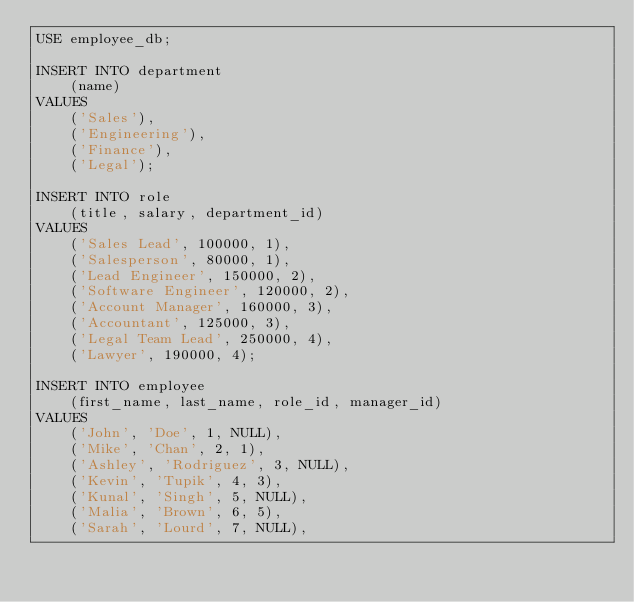Convert code to text. <code><loc_0><loc_0><loc_500><loc_500><_SQL_>USE employee_db;

INSERT INTO department
    (name)
VALUES
    ('Sales'),
    ('Engineering'),
    ('Finance'),
    ('Legal');

INSERT INTO role
    (title, salary, department_id)
VALUES
    ('Sales Lead', 100000, 1),
    ('Salesperson', 80000, 1),
    ('Lead Engineer', 150000, 2),
    ('Software Engineer', 120000, 2),
    ('Account Manager', 160000, 3),
    ('Accountant', 125000, 3),
    ('Legal Team Lead', 250000, 4),
    ('Lawyer', 190000, 4);

INSERT INTO employee
    (first_name, last_name, role_id, manager_id)
VALUES
    ('John', 'Doe', 1, NULL),
    ('Mike', 'Chan', 2, 1),
    ('Ashley', 'Rodriguez', 3, NULL),
    ('Kevin', 'Tupik', 4, 3),
    ('Kunal', 'Singh', 5, NULL),
    ('Malia', 'Brown', 6, 5),
    ('Sarah', 'Lourd', 7, NULL),</code> 